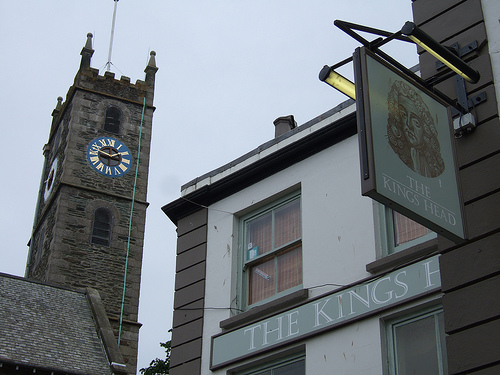If the clock tower could talk, what stories would it tell? If the clock tower could talk, it would recount tales of the town's changing landscape, the growth of the community, and numerous historical events. It might tell of festive occasions celebrated in the town square, times of conflict and peace, and generations of families who have come and gone. It could share stories of long-lost traditions, forgotten heroes, and the evolution of daily life. Each mark on its stone walls would symbolize a different era, a different set of memories from the heart of the town. Describe a scenario in the image if it was during a rainy night. On a rainy night, the image transforms into a moody and atmospheric scene. Raindrops gently tap against the windows of 'THE KINGS HEAD,' their soft sound blending with the occasional rumble of thunder in the distance. The clock tower stands tall against the dark, stormy sky, its face dimly illuminated by the flickering streetlights. The wet cobblestones reflect the soft glow of lamp posts, creating a glistening path leading to the inviting warm lights emanating from the pub. Inside, the locals gather to escape the chill, sharing laughter and stories, bringing warmth and comfort amidst the storm. Create a brief scenario showing the image in a sunny morning in spring. On a sunny morning in spring, the image comes alive with fresh vibrancy. Birds chirp merrily from the clock tower, while a gentle breeze rustles through newly blossomed flowers. Sunlight bathes the buildings, casting a welcoming glow. The streets are filled with townsfolk enjoying the beautiful weather, children playing and vendors setting up market stalls. The pub sign sways lightly, inviting passersby for an afternoon respite. It's a serene and lively morning, symbolizing renewal and community. 